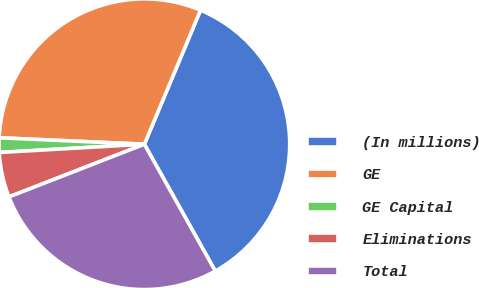Convert chart to OTSL. <chart><loc_0><loc_0><loc_500><loc_500><pie_chart><fcel>(In millions)<fcel>GE<fcel>GE Capital<fcel>Eliminations<fcel>Total<nl><fcel>35.57%<fcel>30.61%<fcel>1.61%<fcel>5.0%<fcel>27.21%<nl></chart> 